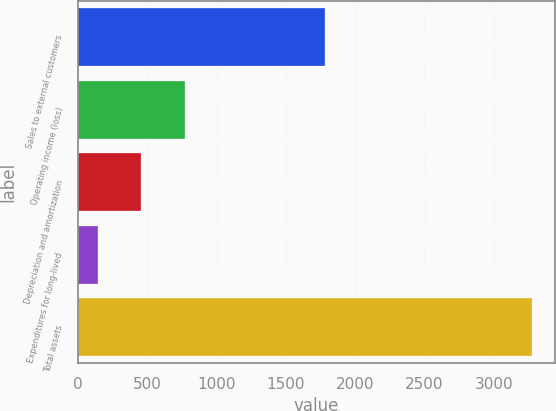Convert chart. <chart><loc_0><loc_0><loc_500><loc_500><bar_chart><fcel>Sales to external customers<fcel>Operating income (loss)<fcel>Depreciation and amortization<fcel>Expenditures for long-lived<fcel>Total assets<nl><fcel>1780.4<fcel>769.78<fcel>456.49<fcel>143.2<fcel>3276.1<nl></chart> 